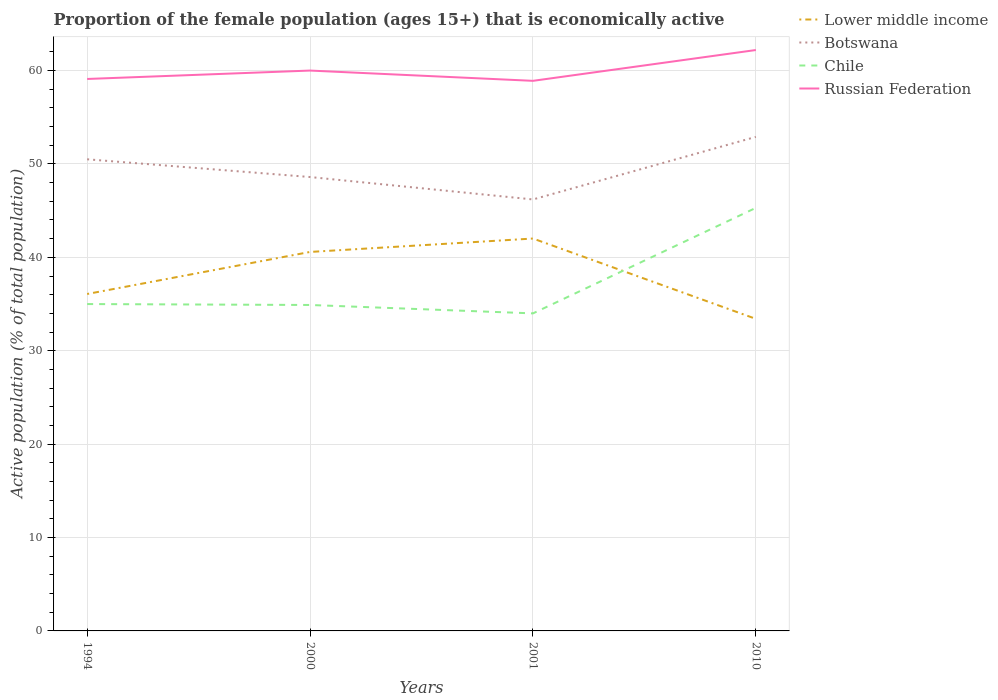How many different coloured lines are there?
Offer a terse response. 4. Does the line corresponding to Chile intersect with the line corresponding to Lower middle income?
Give a very brief answer. Yes. Across all years, what is the maximum proportion of the female population that is economically active in Botswana?
Provide a short and direct response. 46.2. What is the total proportion of the female population that is economically active in Botswana in the graph?
Provide a succinct answer. -6.7. What is the difference between the highest and the second highest proportion of the female population that is economically active in Lower middle income?
Provide a succinct answer. 8.6. What is the difference between the highest and the lowest proportion of the female population that is economically active in Russian Federation?
Ensure brevity in your answer.  1. Are the values on the major ticks of Y-axis written in scientific E-notation?
Offer a terse response. No. Where does the legend appear in the graph?
Offer a very short reply. Top right. How many legend labels are there?
Give a very brief answer. 4. How are the legend labels stacked?
Provide a short and direct response. Vertical. What is the title of the graph?
Keep it short and to the point. Proportion of the female population (ages 15+) that is economically active. What is the label or title of the Y-axis?
Offer a terse response. Active population (% of total population). What is the Active population (% of total population) in Lower middle income in 1994?
Ensure brevity in your answer.  36.08. What is the Active population (% of total population) of Botswana in 1994?
Your answer should be compact. 50.5. What is the Active population (% of total population) in Chile in 1994?
Keep it short and to the point. 35. What is the Active population (% of total population) in Russian Federation in 1994?
Keep it short and to the point. 59.1. What is the Active population (% of total population) in Lower middle income in 2000?
Provide a succinct answer. 40.58. What is the Active population (% of total population) of Botswana in 2000?
Offer a terse response. 48.6. What is the Active population (% of total population) in Chile in 2000?
Give a very brief answer. 34.9. What is the Active population (% of total population) of Russian Federation in 2000?
Your answer should be very brief. 60. What is the Active population (% of total population) in Lower middle income in 2001?
Provide a short and direct response. 42.02. What is the Active population (% of total population) of Botswana in 2001?
Your answer should be compact. 46.2. What is the Active population (% of total population) of Russian Federation in 2001?
Give a very brief answer. 58.9. What is the Active population (% of total population) in Lower middle income in 2010?
Offer a very short reply. 33.41. What is the Active population (% of total population) in Botswana in 2010?
Offer a terse response. 52.9. What is the Active population (% of total population) of Chile in 2010?
Provide a succinct answer. 45.3. What is the Active population (% of total population) in Russian Federation in 2010?
Offer a very short reply. 62.2. Across all years, what is the maximum Active population (% of total population) of Lower middle income?
Ensure brevity in your answer.  42.02. Across all years, what is the maximum Active population (% of total population) of Botswana?
Give a very brief answer. 52.9. Across all years, what is the maximum Active population (% of total population) of Chile?
Ensure brevity in your answer.  45.3. Across all years, what is the maximum Active population (% of total population) of Russian Federation?
Your answer should be compact. 62.2. Across all years, what is the minimum Active population (% of total population) in Lower middle income?
Your answer should be compact. 33.41. Across all years, what is the minimum Active population (% of total population) of Botswana?
Keep it short and to the point. 46.2. Across all years, what is the minimum Active population (% of total population) in Russian Federation?
Give a very brief answer. 58.9. What is the total Active population (% of total population) in Lower middle income in the graph?
Your answer should be compact. 152.08. What is the total Active population (% of total population) of Botswana in the graph?
Keep it short and to the point. 198.2. What is the total Active population (% of total population) in Chile in the graph?
Your response must be concise. 149.2. What is the total Active population (% of total population) in Russian Federation in the graph?
Keep it short and to the point. 240.2. What is the difference between the Active population (% of total population) of Lower middle income in 1994 and that in 2000?
Keep it short and to the point. -4.5. What is the difference between the Active population (% of total population) in Botswana in 1994 and that in 2000?
Provide a succinct answer. 1.9. What is the difference between the Active population (% of total population) in Chile in 1994 and that in 2000?
Keep it short and to the point. 0.1. What is the difference between the Active population (% of total population) in Russian Federation in 1994 and that in 2000?
Provide a succinct answer. -0.9. What is the difference between the Active population (% of total population) of Lower middle income in 1994 and that in 2001?
Offer a terse response. -5.94. What is the difference between the Active population (% of total population) in Botswana in 1994 and that in 2001?
Offer a terse response. 4.3. What is the difference between the Active population (% of total population) of Russian Federation in 1994 and that in 2001?
Make the answer very short. 0.2. What is the difference between the Active population (% of total population) of Lower middle income in 1994 and that in 2010?
Offer a terse response. 2.66. What is the difference between the Active population (% of total population) of Chile in 1994 and that in 2010?
Keep it short and to the point. -10.3. What is the difference between the Active population (% of total population) of Lower middle income in 2000 and that in 2001?
Your answer should be compact. -1.44. What is the difference between the Active population (% of total population) in Chile in 2000 and that in 2001?
Your response must be concise. 0.9. What is the difference between the Active population (% of total population) in Russian Federation in 2000 and that in 2001?
Your answer should be compact. 1.1. What is the difference between the Active population (% of total population) in Lower middle income in 2000 and that in 2010?
Your answer should be compact. 7.17. What is the difference between the Active population (% of total population) in Lower middle income in 2001 and that in 2010?
Your answer should be compact. 8.6. What is the difference between the Active population (% of total population) of Botswana in 2001 and that in 2010?
Provide a short and direct response. -6.7. What is the difference between the Active population (% of total population) in Chile in 2001 and that in 2010?
Keep it short and to the point. -11.3. What is the difference between the Active population (% of total population) in Russian Federation in 2001 and that in 2010?
Your answer should be compact. -3.3. What is the difference between the Active population (% of total population) of Lower middle income in 1994 and the Active population (% of total population) of Botswana in 2000?
Provide a succinct answer. -12.52. What is the difference between the Active population (% of total population) in Lower middle income in 1994 and the Active population (% of total population) in Chile in 2000?
Give a very brief answer. 1.18. What is the difference between the Active population (% of total population) of Lower middle income in 1994 and the Active population (% of total population) of Russian Federation in 2000?
Make the answer very short. -23.92. What is the difference between the Active population (% of total population) in Botswana in 1994 and the Active population (% of total population) in Russian Federation in 2000?
Ensure brevity in your answer.  -9.5. What is the difference between the Active population (% of total population) of Lower middle income in 1994 and the Active population (% of total population) of Botswana in 2001?
Ensure brevity in your answer.  -10.12. What is the difference between the Active population (% of total population) in Lower middle income in 1994 and the Active population (% of total population) in Chile in 2001?
Give a very brief answer. 2.08. What is the difference between the Active population (% of total population) of Lower middle income in 1994 and the Active population (% of total population) of Russian Federation in 2001?
Your answer should be very brief. -22.82. What is the difference between the Active population (% of total population) of Botswana in 1994 and the Active population (% of total population) of Russian Federation in 2001?
Keep it short and to the point. -8.4. What is the difference between the Active population (% of total population) in Chile in 1994 and the Active population (% of total population) in Russian Federation in 2001?
Your response must be concise. -23.9. What is the difference between the Active population (% of total population) of Lower middle income in 1994 and the Active population (% of total population) of Botswana in 2010?
Give a very brief answer. -16.82. What is the difference between the Active population (% of total population) of Lower middle income in 1994 and the Active population (% of total population) of Chile in 2010?
Your answer should be compact. -9.22. What is the difference between the Active population (% of total population) of Lower middle income in 1994 and the Active population (% of total population) of Russian Federation in 2010?
Provide a succinct answer. -26.12. What is the difference between the Active population (% of total population) in Botswana in 1994 and the Active population (% of total population) in Chile in 2010?
Ensure brevity in your answer.  5.2. What is the difference between the Active population (% of total population) in Chile in 1994 and the Active population (% of total population) in Russian Federation in 2010?
Your response must be concise. -27.2. What is the difference between the Active population (% of total population) in Lower middle income in 2000 and the Active population (% of total population) in Botswana in 2001?
Offer a very short reply. -5.62. What is the difference between the Active population (% of total population) in Lower middle income in 2000 and the Active population (% of total population) in Chile in 2001?
Offer a very short reply. 6.58. What is the difference between the Active population (% of total population) in Lower middle income in 2000 and the Active population (% of total population) in Russian Federation in 2001?
Your answer should be compact. -18.32. What is the difference between the Active population (% of total population) in Chile in 2000 and the Active population (% of total population) in Russian Federation in 2001?
Make the answer very short. -24. What is the difference between the Active population (% of total population) of Lower middle income in 2000 and the Active population (% of total population) of Botswana in 2010?
Ensure brevity in your answer.  -12.32. What is the difference between the Active population (% of total population) in Lower middle income in 2000 and the Active population (% of total population) in Chile in 2010?
Your answer should be compact. -4.72. What is the difference between the Active population (% of total population) in Lower middle income in 2000 and the Active population (% of total population) in Russian Federation in 2010?
Offer a very short reply. -21.62. What is the difference between the Active population (% of total population) in Chile in 2000 and the Active population (% of total population) in Russian Federation in 2010?
Keep it short and to the point. -27.3. What is the difference between the Active population (% of total population) in Lower middle income in 2001 and the Active population (% of total population) in Botswana in 2010?
Provide a succinct answer. -10.88. What is the difference between the Active population (% of total population) in Lower middle income in 2001 and the Active population (% of total population) in Chile in 2010?
Provide a succinct answer. -3.28. What is the difference between the Active population (% of total population) of Lower middle income in 2001 and the Active population (% of total population) of Russian Federation in 2010?
Your answer should be compact. -20.18. What is the difference between the Active population (% of total population) of Chile in 2001 and the Active population (% of total population) of Russian Federation in 2010?
Offer a terse response. -28.2. What is the average Active population (% of total population) in Lower middle income per year?
Your answer should be very brief. 38.02. What is the average Active population (% of total population) in Botswana per year?
Give a very brief answer. 49.55. What is the average Active population (% of total population) of Chile per year?
Offer a very short reply. 37.3. What is the average Active population (% of total population) in Russian Federation per year?
Keep it short and to the point. 60.05. In the year 1994, what is the difference between the Active population (% of total population) in Lower middle income and Active population (% of total population) in Botswana?
Make the answer very short. -14.42. In the year 1994, what is the difference between the Active population (% of total population) of Lower middle income and Active population (% of total population) of Chile?
Give a very brief answer. 1.08. In the year 1994, what is the difference between the Active population (% of total population) of Lower middle income and Active population (% of total population) of Russian Federation?
Make the answer very short. -23.02. In the year 1994, what is the difference between the Active population (% of total population) of Chile and Active population (% of total population) of Russian Federation?
Offer a very short reply. -24.1. In the year 2000, what is the difference between the Active population (% of total population) of Lower middle income and Active population (% of total population) of Botswana?
Your answer should be compact. -8.02. In the year 2000, what is the difference between the Active population (% of total population) in Lower middle income and Active population (% of total population) in Chile?
Keep it short and to the point. 5.68. In the year 2000, what is the difference between the Active population (% of total population) in Lower middle income and Active population (% of total population) in Russian Federation?
Ensure brevity in your answer.  -19.42. In the year 2000, what is the difference between the Active population (% of total population) of Botswana and Active population (% of total population) of Chile?
Make the answer very short. 13.7. In the year 2000, what is the difference between the Active population (% of total population) of Chile and Active population (% of total population) of Russian Federation?
Your response must be concise. -25.1. In the year 2001, what is the difference between the Active population (% of total population) in Lower middle income and Active population (% of total population) in Botswana?
Your answer should be compact. -4.18. In the year 2001, what is the difference between the Active population (% of total population) of Lower middle income and Active population (% of total population) of Chile?
Keep it short and to the point. 8.02. In the year 2001, what is the difference between the Active population (% of total population) in Lower middle income and Active population (% of total population) in Russian Federation?
Provide a short and direct response. -16.88. In the year 2001, what is the difference between the Active population (% of total population) in Botswana and Active population (% of total population) in Russian Federation?
Make the answer very short. -12.7. In the year 2001, what is the difference between the Active population (% of total population) of Chile and Active population (% of total population) of Russian Federation?
Your answer should be compact. -24.9. In the year 2010, what is the difference between the Active population (% of total population) in Lower middle income and Active population (% of total population) in Botswana?
Your answer should be very brief. -19.49. In the year 2010, what is the difference between the Active population (% of total population) of Lower middle income and Active population (% of total population) of Chile?
Provide a succinct answer. -11.89. In the year 2010, what is the difference between the Active population (% of total population) of Lower middle income and Active population (% of total population) of Russian Federation?
Ensure brevity in your answer.  -28.79. In the year 2010, what is the difference between the Active population (% of total population) in Botswana and Active population (% of total population) in Russian Federation?
Your answer should be very brief. -9.3. In the year 2010, what is the difference between the Active population (% of total population) in Chile and Active population (% of total population) in Russian Federation?
Offer a very short reply. -16.9. What is the ratio of the Active population (% of total population) in Lower middle income in 1994 to that in 2000?
Provide a short and direct response. 0.89. What is the ratio of the Active population (% of total population) in Botswana in 1994 to that in 2000?
Your response must be concise. 1.04. What is the ratio of the Active population (% of total population) in Chile in 1994 to that in 2000?
Ensure brevity in your answer.  1. What is the ratio of the Active population (% of total population) of Lower middle income in 1994 to that in 2001?
Keep it short and to the point. 0.86. What is the ratio of the Active population (% of total population) of Botswana in 1994 to that in 2001?
Your response must be concise. 1.09. What is the ratio of the Active population (% of total population) of Chile in 1994 to that in 2001?
Make the answer very short. 1.03. What is the ratio of the Active population (% of total population) of Russian Federation in 1994 to that in 2001?
Give a very brief answer. 1. What is the ratio of the Active population (% of total population) of Lower middle income in 1994 to that in 2010?
Offer a very short reply. 1.08. What is the ratio of the Active population (% of total population) in Botswana in 1994 to that in 2010?
Offer a terse response. 0.95. What is the ratio of the Active population (% of total population) in Chile in 1994 to that in 2010?
Give a very brief answer. 0.77. What is the ratio of the Active population (% of total population) of Russian Federation in 1994 to that in 2010?
Your response must be concise. 0.95. What is the ratio of the Active population (% of total population) of Lower middle income in 2000 to that in 2001?
Your response must be concise. 0.97. What is the ratio of the Active population (% of total population) of Botswana in 2000 to that in 2001?
Offer a terse response. 1.05. What is the ratio of the Active population (% of total population) in Chile in 2000 to that in 2001?
Offer a very short reply. 1.03. What is the ratio of the Active population (% of total population) in Russian Federation in 2000 to that in 2001?
Your answer should be very brief. 1.02. What is the ratio of the Active population (% of total population) in Lower middle income in 2000 to that in 2010?
Keep it short and to the point. 1.21. What is the ratio of the Active population (% of total population) in Botswana in 2000 to that in 2010?
Give a very brief answer. 0.92. What is the ratio of the Active population (% of total population) of Chile in 2000 to that in 2010?
Ensure brevity in your answer.  0.77. What is the ratio of the Active population (% of total population) of Russian Federation in 2000 to that in 2010?
Provide a short and direct response. 0.96. What is the ratio of the Active population (% of total population) in Lower middle income in 2001 to that in 2010?
Keep it short and to the point. 1.26. What is the ratio of the Active population (% of total population) in Botswana in 2001 to that in 2010?
Offer a terse response. 0.87. What is the ratio of the Active population (% of total population) of Chile in 2001 to that in 2010?
Ensure brevity in your answer.  0.75. What is the ratio of the Active population (% of total population) of Russian Federation in 2001 to that in 2010?
Give a very brief answer. 0.95. What is the difference between the highest and the second highest Active population (% of total population) in Lower middle income?
Provide a short and direct response. 1.44. What is the difference between the highest and the second highest Active population (% of total population) of Russian Federation?
Offer a terse response. 2.2. What is the difference between the highest and the lowest Active population (% of total population) in Lower middle income?
Offer a terse response. 8.6. What is the difference between the highest and the lowest Active population (% of total population) in Chile?
Your answer should be very brief. 11.3. 